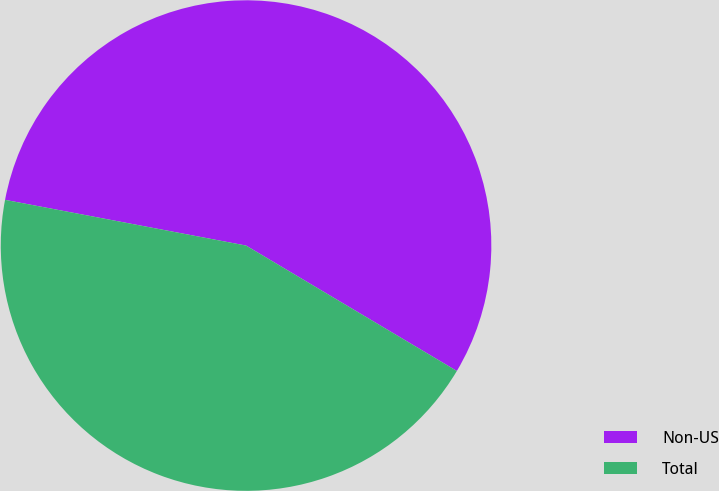<chart> <loc_0><loc_0><loc_500><loc_500><pie_chart><fcel>Non-US<fcel>Total<nl><fcel>55.56%<fcel>44.44%<nl></chart> 